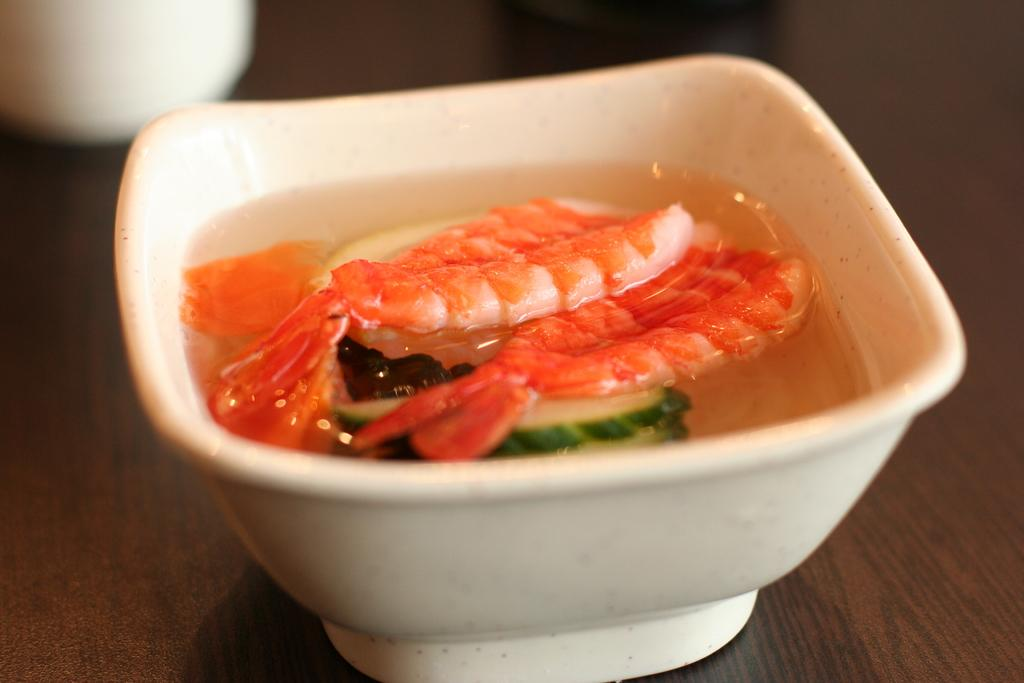What is present on the table in the image? There is a bowl on the table in the image. What is inside the bowl? There is soup in the bowl. Can you describe the background of the image? The background of the image is blurred. What type of brick is being used to build the volleyball court in the image? There is no brick or volleyball court present in the image. 